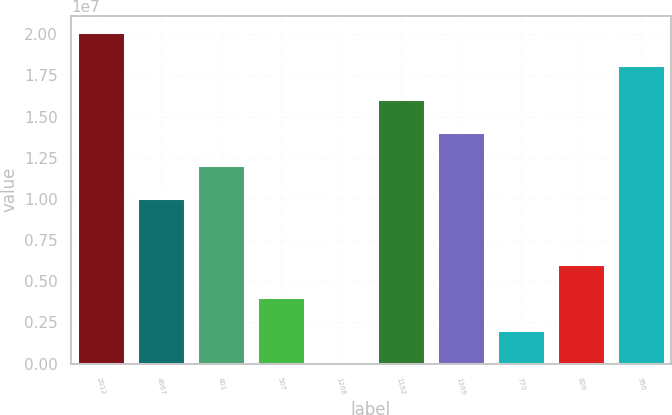Convert chart. <chart><loc_0><loc_0><loc_500><loc_500><bar_chart><fcel>2012<fcel>4967<fcel>401<fcel>507<fcel>1268<fcel>1162<fcel>1369<fcel>770<fcel>826<fcel>956<nl><fcel>2.0122e+07<fcel>1.0061e+07<fcel>1.20732e+07<fcel>4.0244e+06<fcel>1<fcel>1.60976e+07<fcel>1.40854e+07<fcel>2.0122e+06<fcel>6.0366e+06<fcel>1.81098e+07<nl></chart> 